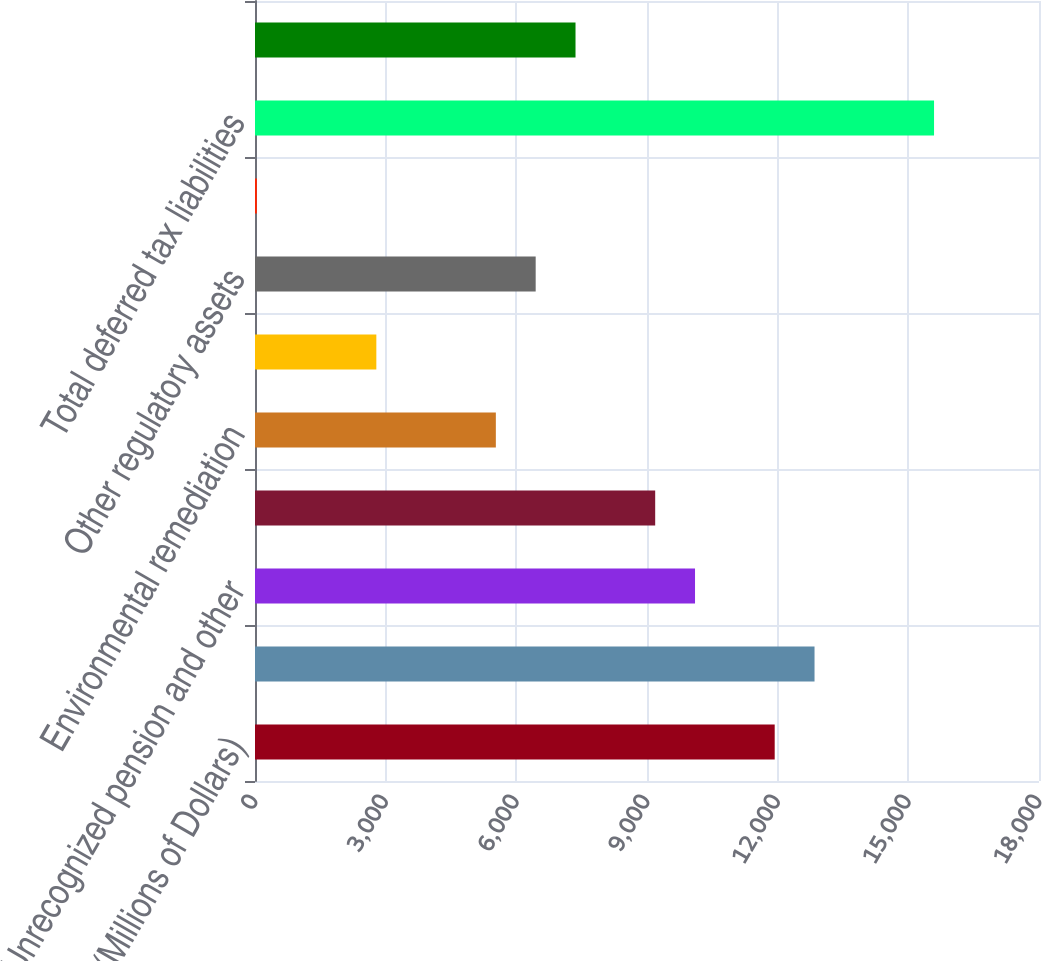Convert chart to OTSL. <chart><loc_0><loc_0><loc_500><loc_500><bar_chart><fcel>(Millions of Dollars)<fcel>Property basis differences<fcel>Unrecognized pension and other<fcel>Regulatory asset - future<fcel>Environmental remediation<fcel>Deferred storm costs<fcel>Other regulatory assets<fcel>Unamortized investment tax<fcel>Total deferred tax liabilities<fcel>Accrued pension and other<nl><fcel>11931.8<fcel>12846.4<fcel>10102.6<fcel>9188<fcel>5529.6<fcel>2785.8<fcel>6444.2<fcel>42<fcel>15590.2<fcel>7358.8<nl></chart> 